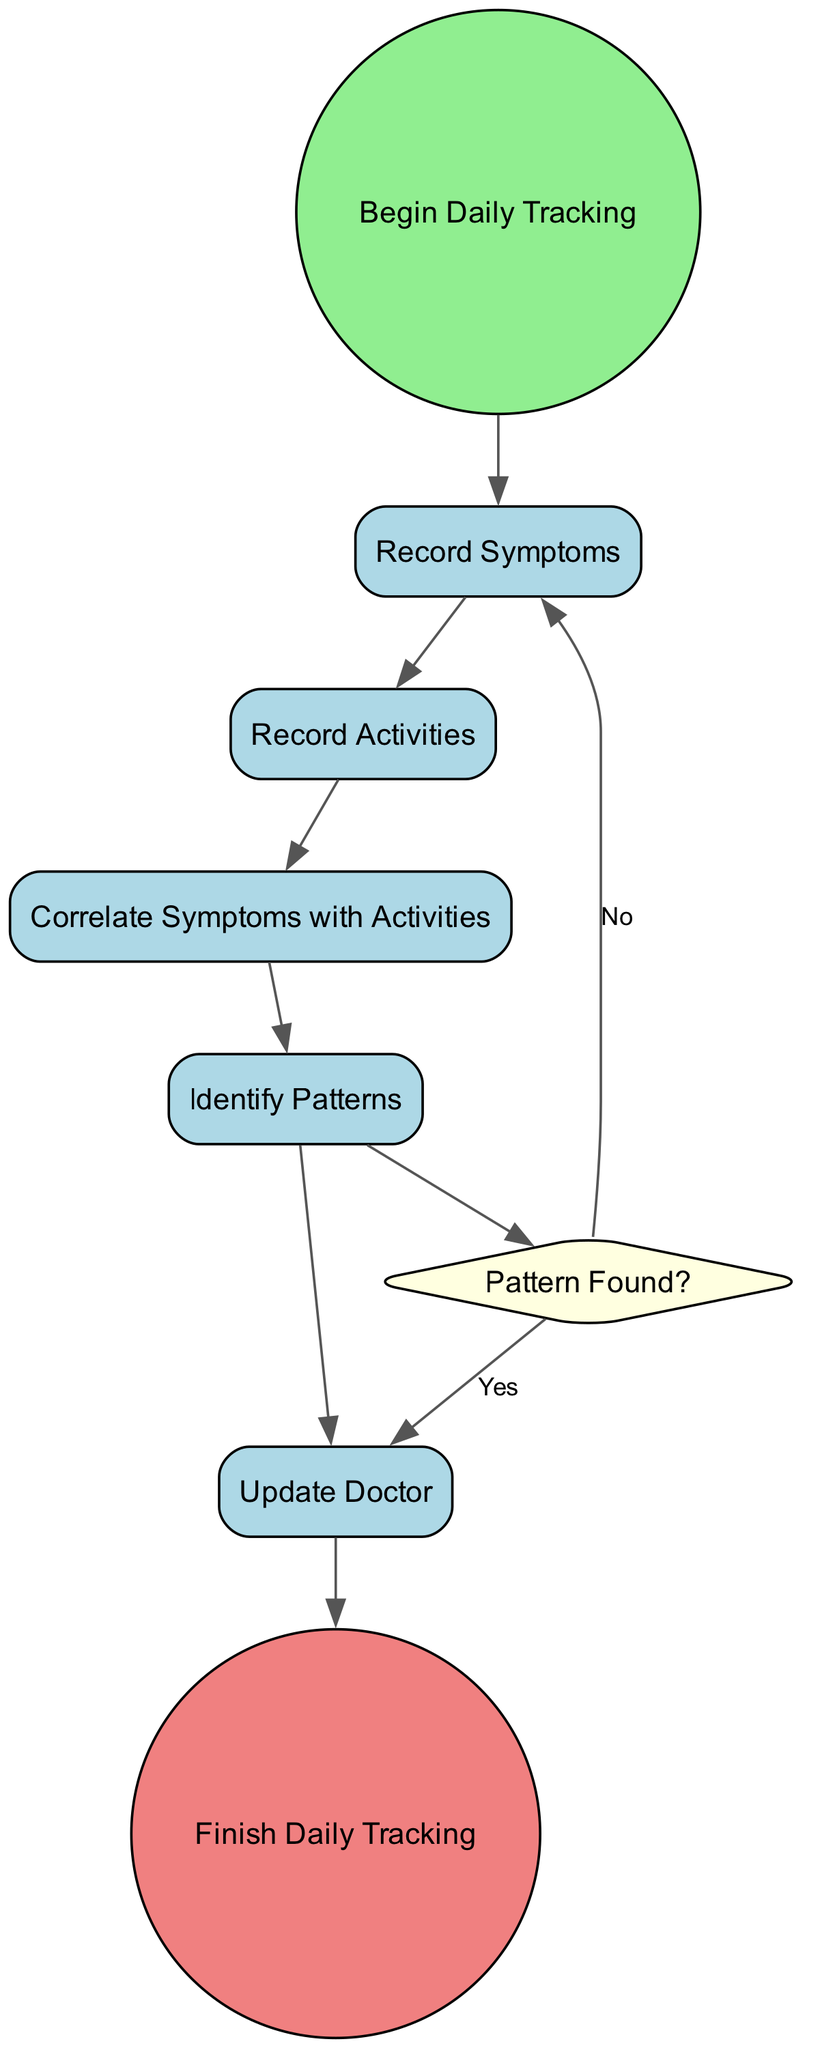What is the first activity after starting? The diagram shows that after the "Begin Daily Tracking" start event, the first activity that follows is "Record Symptoms." This is deduced by tracing the edge leading from the start event to the first activity node.
Answer: Record Symptoms How many activities are there in the diagram? By counting the nodes that represent activities, we find there are five activities in total: "Record Symptoms," "Record Activities," "Correlate Symptoms with Activities," "Identify Patterns," and "Update Doctor."
Answer: Five What happens if a pattern is found? If the decision point "Pattern Found?" results in a "Yes," the flow of the diagram directs to the "Update Doctor" activity, as indicated by the edge leading from the decision node labeled with the option "Yes."
Answer: Update Doctor What is the last activity before finishing? The diagram indicates that the last activity before reaching the end event "Finish Daily Tracking" is "Update Doctor." This is determined by observing the flow and the edge that connects to the end event.
Answer: Update Doctor Which activity logs daily activities? The activity that logs daily activities, including exercise, meals, medication, and stress levels, is labeled "Record Activities." This is identified by inspecting the descriptions associated with each activity node in the diagram.
Answer: Record Activities What decision point exists in the diagram? The single decision point presented in the diagram is "Pattern Found?" This is evident as it is represented by a diamond-shaped node, which is characteristic of decision points in flow diagrams.
Answer: Pattern Found? If no pattern is found, where does the flow go next? If there is no pattern found, the flow returns to the "Record Symptoms" activity according to the "No" option linked from the decision point. This can be seen by examining the edges that stem from the decision node.
Answer: Record Symptoms How many edges connect the activities? Upon inspection, there are a total of six edges connecting the activities together, which can be counted by observing the directed connections between each activity node.
Answer: Six 